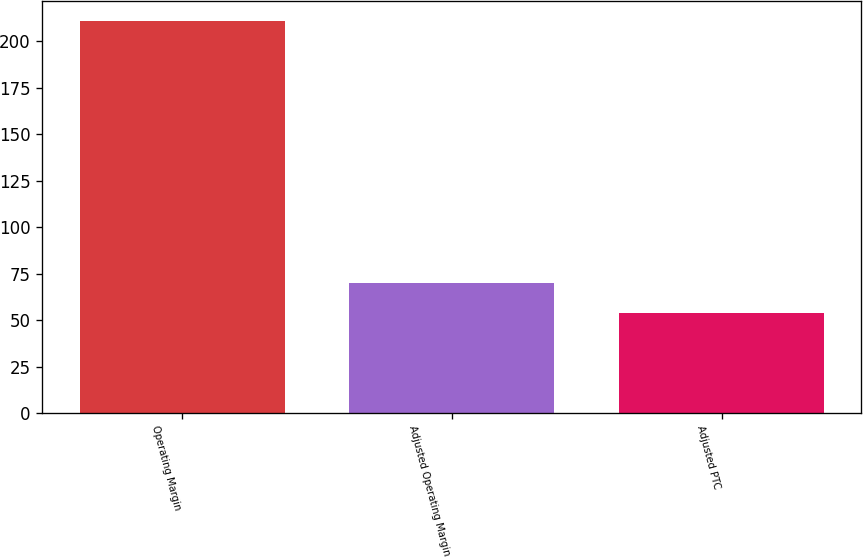Convert chart. <chart><loc_0><loc_0><loc_500><loc_500><bar_chart><fcel>Operating Margin<fcel>Adjusted Operating Margin<fcel>Adjusted PTC<nl><fcel>211<fcel>69.7<fcel>54<nl></chart> 